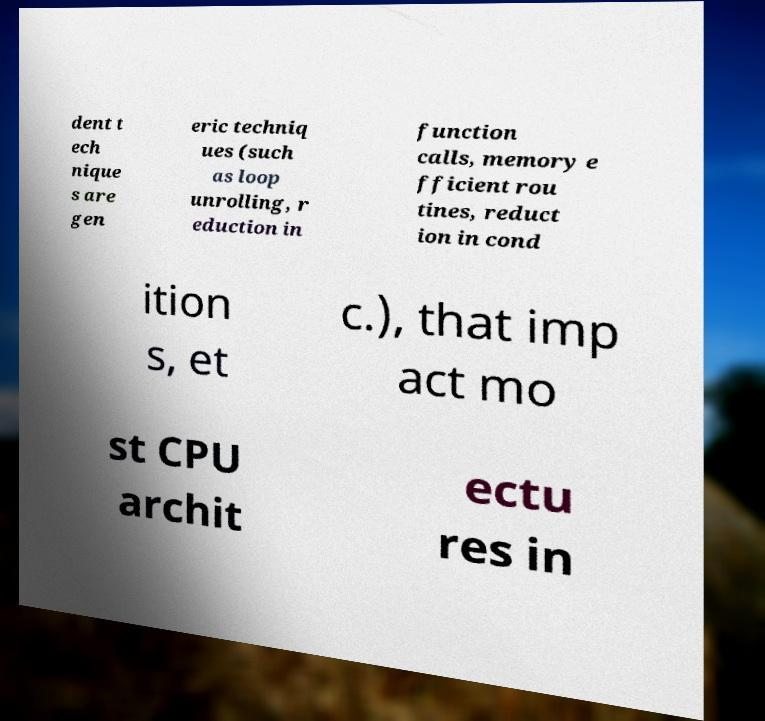I need the written content from this picture converted into text. Can you do that? dent t ech nique s are gen eric techniq ues (such as loop unrolling, r eduction in function calls, memory e fficient rou tines, reduct ion in cond ition s, et c.), that imp act mo st CPU archit ectu res in 